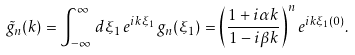<formula> <loc_0><loc_0><loc_500><loc_500>\tilde { g } _ { n } ( k ) = \int _ { - \infty } ^ { \infty } \, d \xi _ { 1 } \, e ^ { i k \xi _ { 1 } } \, g _ { n } ( \xi _ { 1 } ) = \left ( \frac { 1 + i \alpha k } { 1 - i \beta k } \right ) ^ { n } e ^ { i k \xi _ { 1 } ( 0 ) } .</formula> 